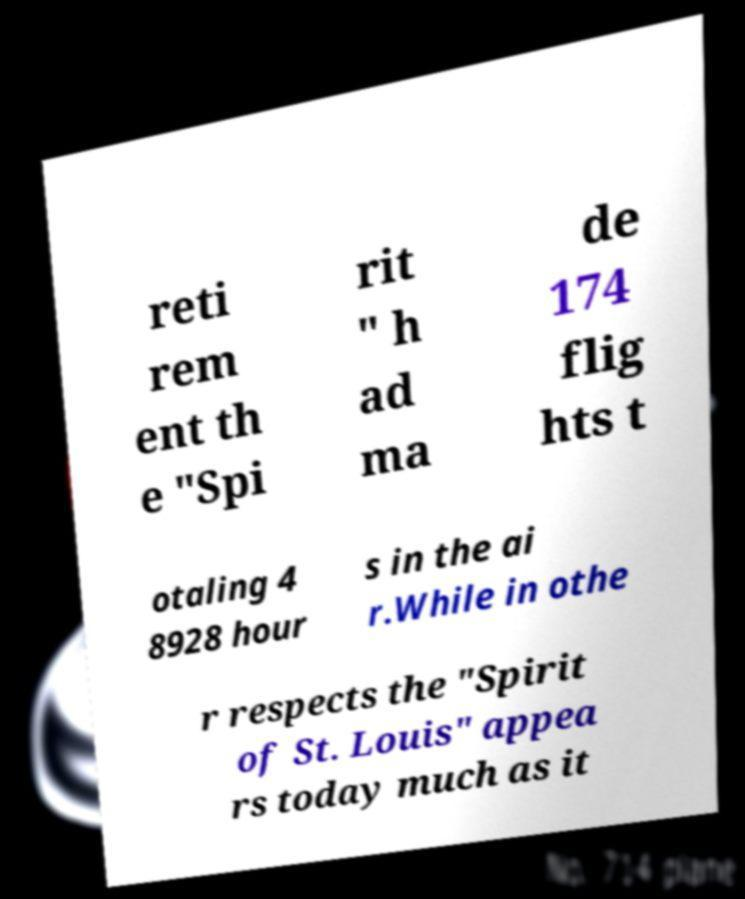Could you extract and type out the text from this image? reti rem ent th e "Spi rit " h ad ma de 174 flig hts t otaling 4 8928 hour s in the ai r.While in othe r respects the "Spirit of St. Louis" appea rs today much as it 